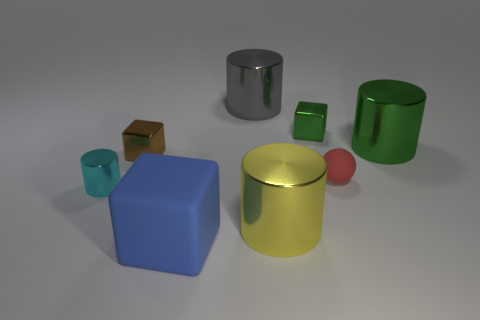Add 2 gray metallic cylinders. How many objects exist? 10 Subtract all spheres. How many objects are left? 7 Subtract 0 gray blocks. How many objects are left? 8 Subtract all small brown cubes. Subtract all large green cylinders. How many objects are left? 6 Add 8 green cubes. How many green cubes are left? 9 Add 7 tiny purple shiny cylinders. How many tiny purple shiny cylinders exist? 7 